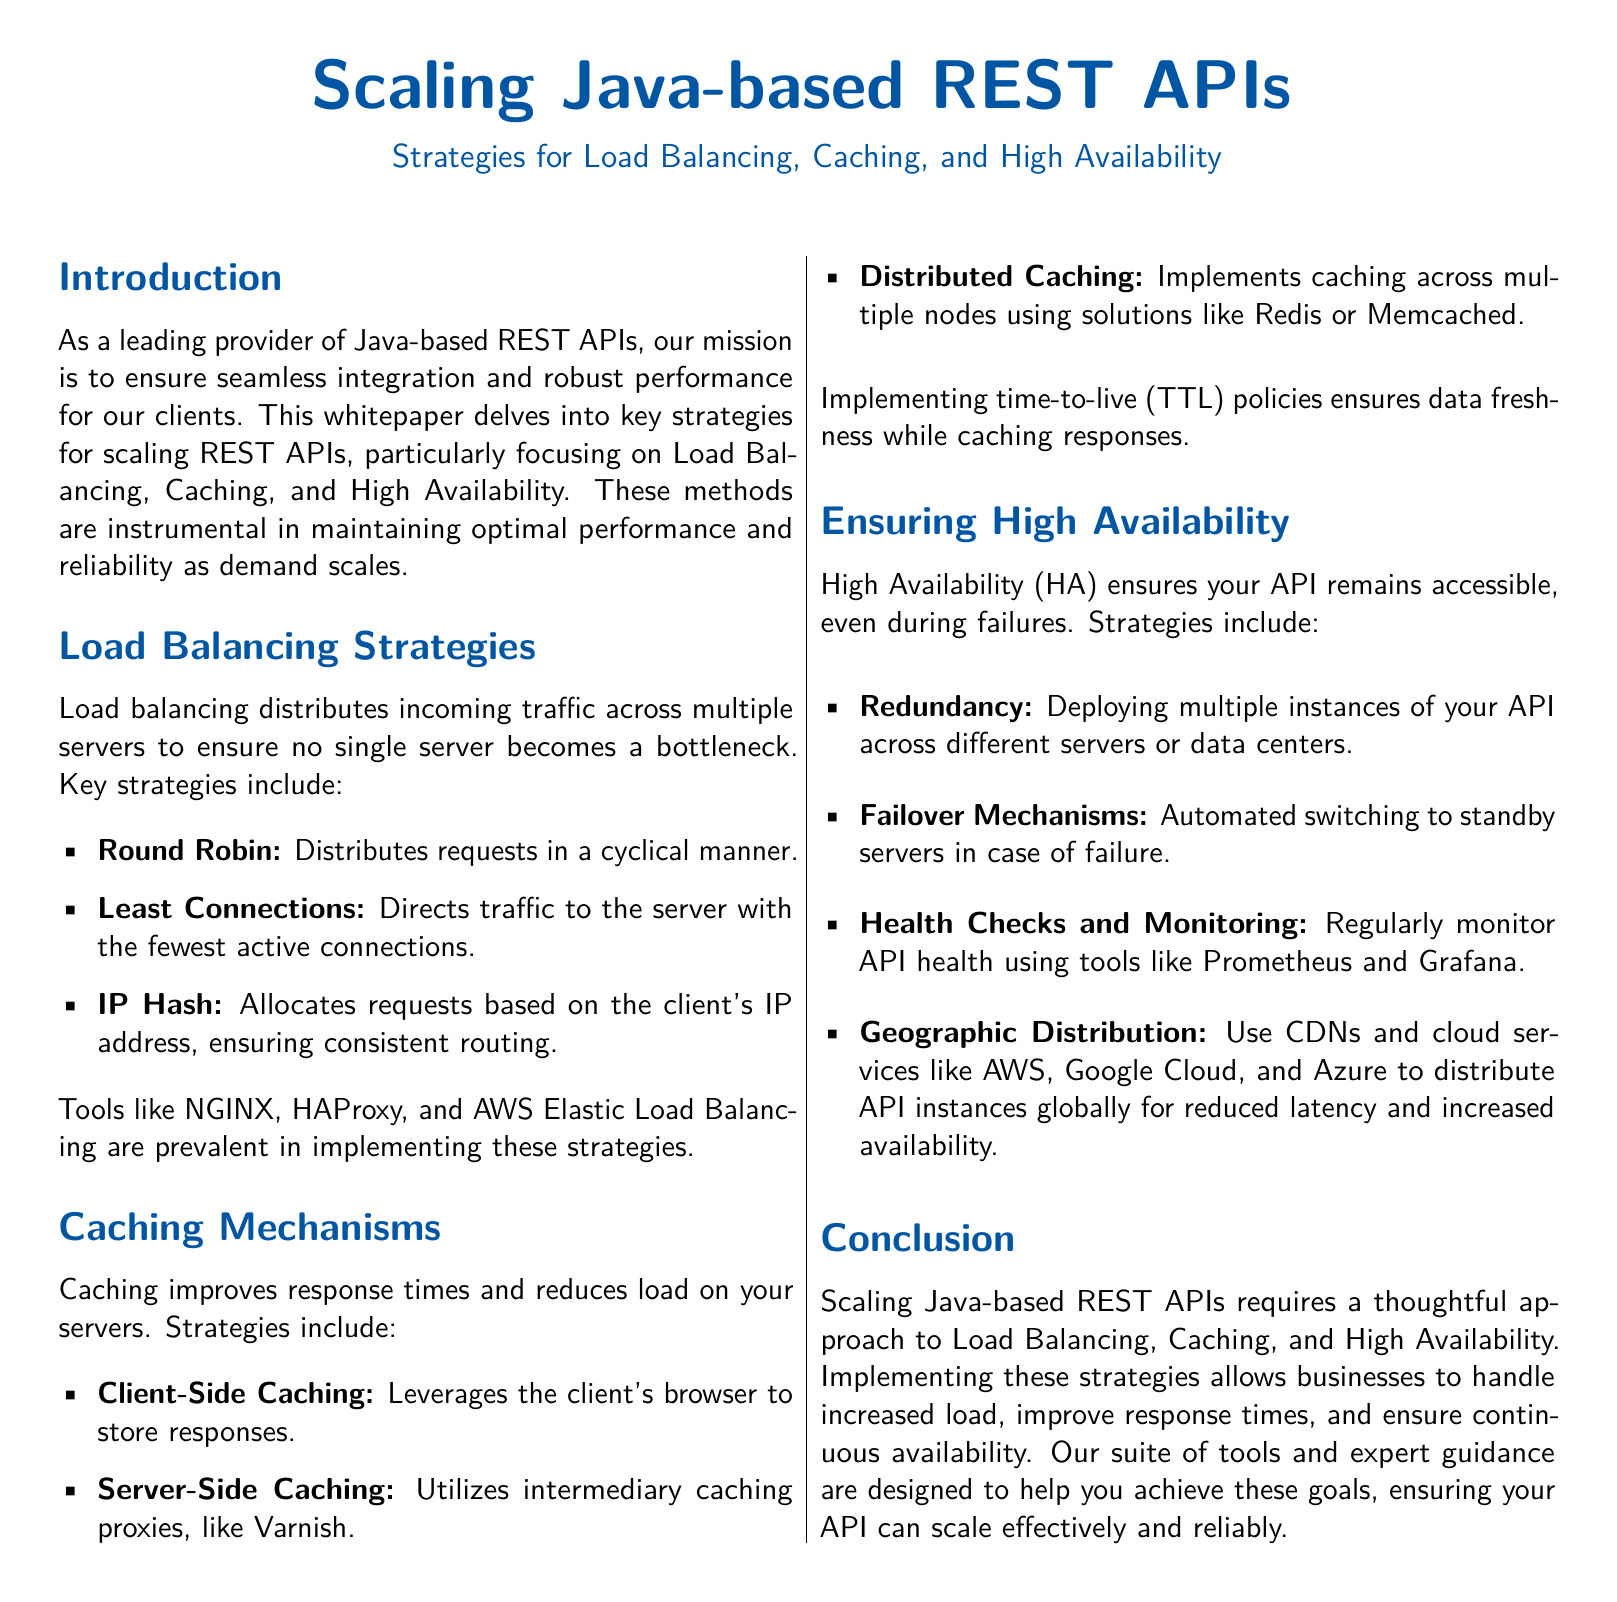What are the three main strategies for scaling REST APIs? The document specifies Load Balancing, Caching, and High Availability as the three main strategies for scaling REST APIs.
Answer: Load Balancing, Caching, and High Availability Name one load balancing strategy mentioned in the document. The document lists several load balancing strategies; one example is Round Robin.
Answer: Round Robin What is one tool used for implementing load balancing? The document mentions several tools for load balancing, including NGINX.
Answer: NGINX Which caching strategy involves using the client's browser? The document defines Client-Side Caching as leveraging the client's browser to store responses.
Answer: Client-Side Caching What does High Availability ensure? The document explains that High Availability ensures your API remains accessible, even during failures.
Answer: Accessibility Name a caching solution mentioned in the document. The document refers to Redis as an example of a distributed caching solution.
Answer: Redis What strategy involves using multiple instances across servers? The document states that Redundancy is the strategy that involves deploying multiple instances of the API.
Answer: Redundancy Which monitoring tools are recommended in the document? The document mentions Prometheus and Grafana as tools for regularly monitoring API health.
Answer: Prometheus and Grafana What does TTL stand for in caching policies? The document uses the term Time-to-Live (TTL) to ensure data freshness while caching responses.
Answer: Time-to-Live 